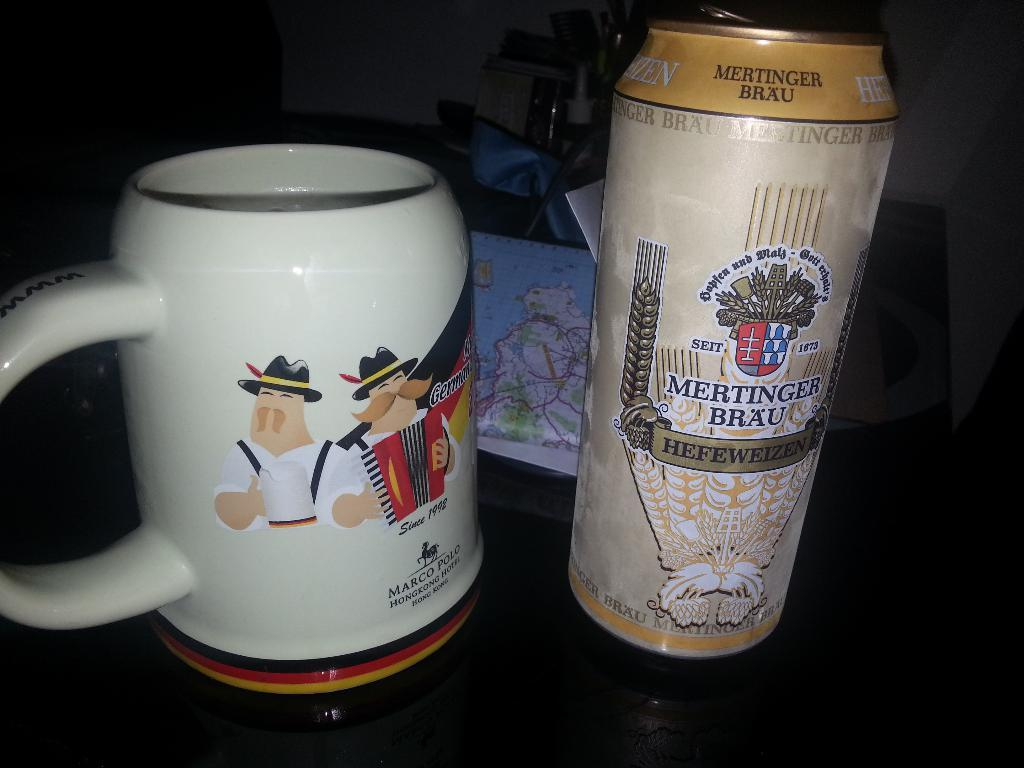Provide a one-sentence caption for the provided image. A can of Mertinger Brau sits next to a mug with cartoons of German men. 